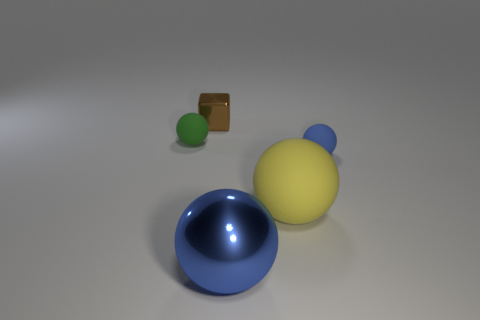Subtract all yellow spheres. How many spheres are left? 3 Subtract all purple balls. Subtract all purple blocks. How many balls are left? 4 Add 4 small green objects. How many objects exist? 9 Subtract all cubes. How many objects are left? 4 Subtract all tiny cubes. Subtract all small brown shiny blocks. How many objects are left? 3 Add 5 small spheres. How many small spheres are left? 7 Add 4 tiny gray cubes. How many tiny gray cubes exist? 4 Subtract 0 cyan cubes. How many objects are left? 5 